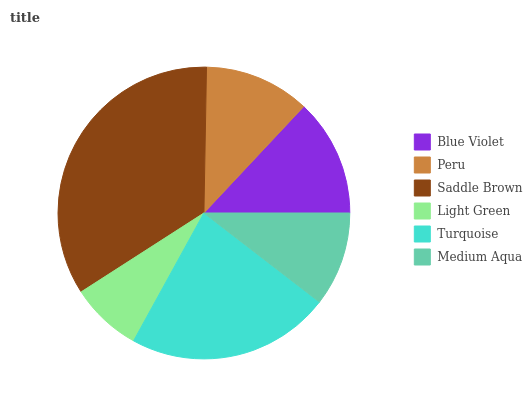Is Light Green the minimum?
Answer yes or no. Yes. Is Saddle Brown the maximum?
Answer yes or no. Yes. Is Peru the minimum?
Answer yes or no. No. Is Peru the maximum?
Answer yes or no. No. Is Blue Violet greater than Peru?
Answer yes or no. Yes. Is Peru less than Blue Violet?
Answer yes or no. Yes. Is Peru greater than Blue Violet?
Answer yes or no. No. Is Blue Violet less than Peru?
Answer yes or no. No. Is Blue Violet the high median?
Answer yes or no. Yes. Is Peru the low median?
Answer yes or no. Yes. Is Saddle Brown the high median?
Answer yes or no. No. Is Light Green the low median?
Answer yes or no. No. 